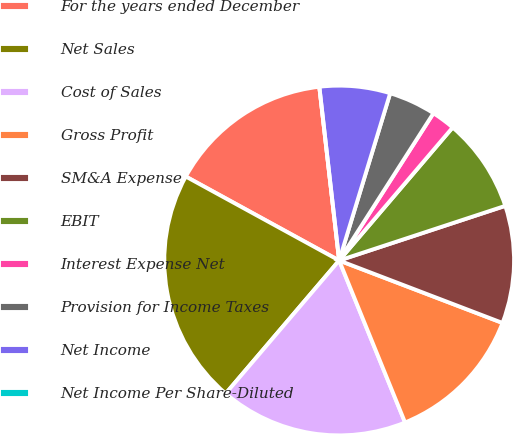Convert chart to OTSL. <chart><loc_0><loc_0><loc_500><loc_500><pie_chart><fcel>For the years ended December<fcel>Net Sales<fcel>Cost of Sales<fcel>Gross Profit<fcel>SM&A Expense<fcel>EBIT<fcel>Interest Expense Net<fcel>Provision for Income Taxes<fcel>Net Income<fcel>Net Income Per Share-Diluted<nl><fcel>15.22%<fcel>21.73%<fcel>17.39%<fcel>13.04%<fcel>10.87%<fcel>8.7%<fcel>2.18%<fcel>4.35%<fcel>6.52%<fcel>0.0%<nl></chart> 